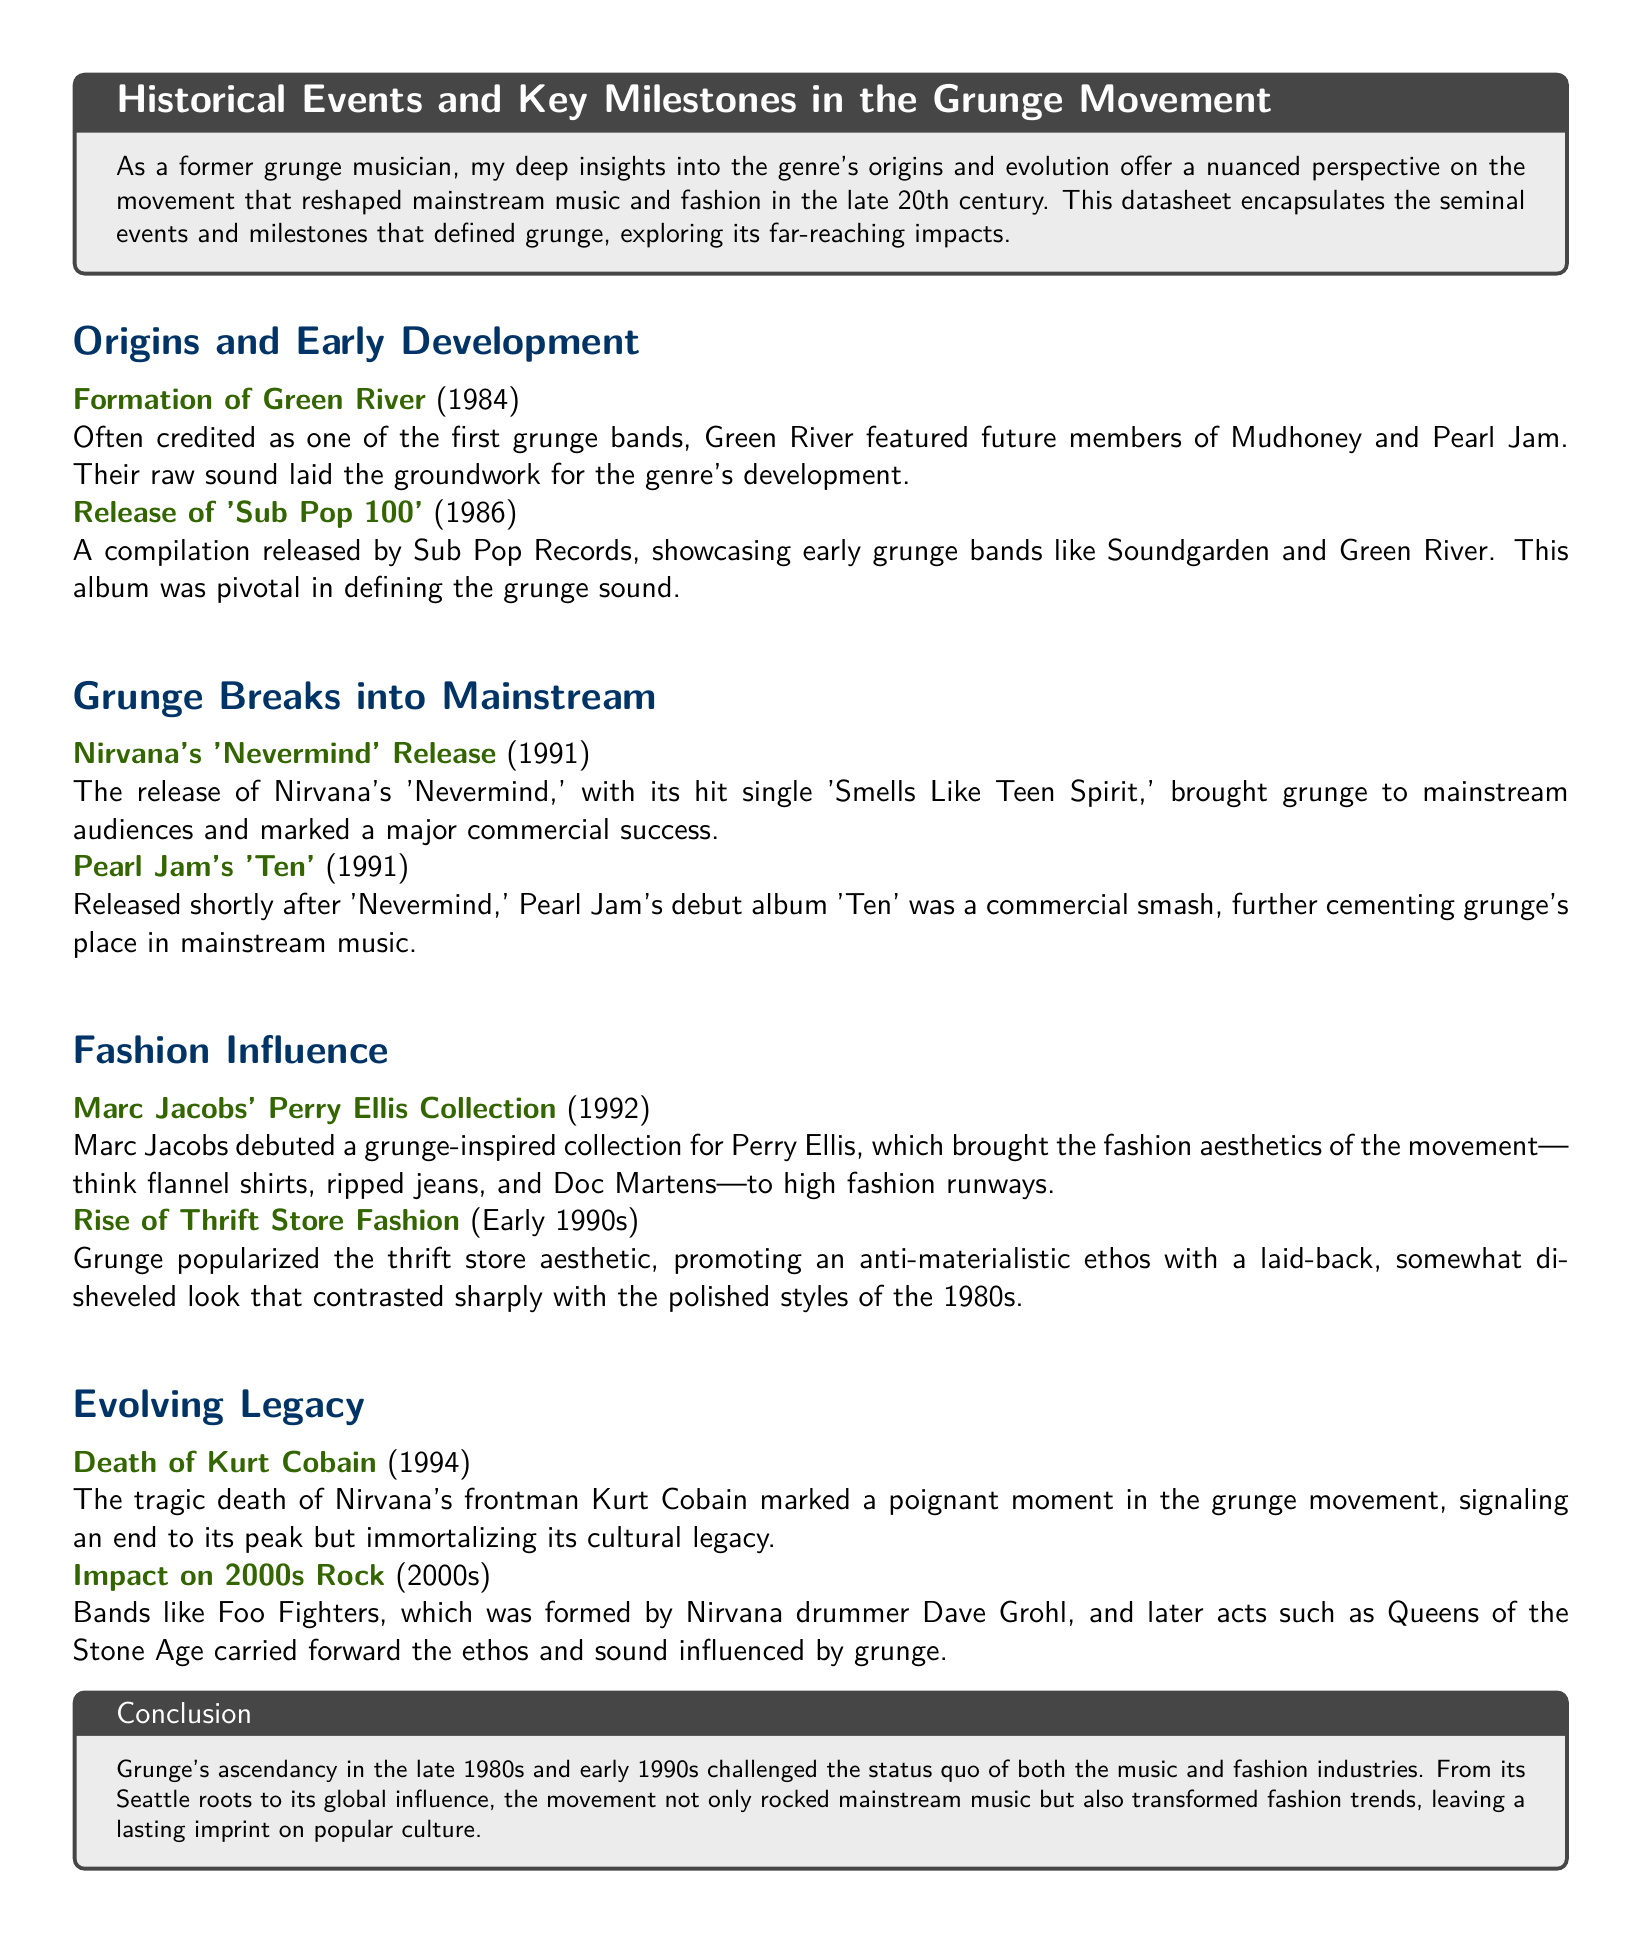What band is often credited as one of the first grunge bands? The document states that Green River is often credited as one of the first grunge bands.
Answer: Green River What year was Nirvana's 'Nevermind' released? According to the document, Nirvana's 'Nevermind' was released in 1991.
Answer: 1991 Which fashion brand featured a grunge-inspired collection in 1992? The document identifies Marc Jacobs as the designer who debuted a grunge-inspired collection for Perry Ellis in 1992.
Answer: Perry Ellis What significant event happened in 1994 related to the grunge movement? The document notes that the death of Kurt Cobain in 1994 marked a poignant moment in the grunge movement.
Answer: Death of Kurt Cobain Which album was released shortly after 'Nevermind'? The document mentions Pearl Jam's debut album 'Ten' being released shortly after 'Nevermind'.
Answer: Ten What aesthetic did grunge popularize in the early 1990s? The document states that grunge popularized the thrift store aesthetic in the early 1990s.
Answer: Thrift store aesthetic How did grunge influence the fashion industry according to the document? The document describes that grunge brought an anti-materialistic ethos to fashion, contrasting sharply with the polished styles of the 1980s.
Answer: Anti-materialistic ethos Which band is mentioned as carrying forward the ethos influenced by grunge in the 2000s? According to the document, Foo Fighters is mentioned as a band that carried forward the ethos influenced by grunge.
Answer: Foo Fighters What milestone marked the rise of grunge into mainstream music? The document highlights the release of Nirvana's 'Nevermind' as a milestone that brought grunge into mainstream music.
Answer: Nirvana's 'Nevermind' 